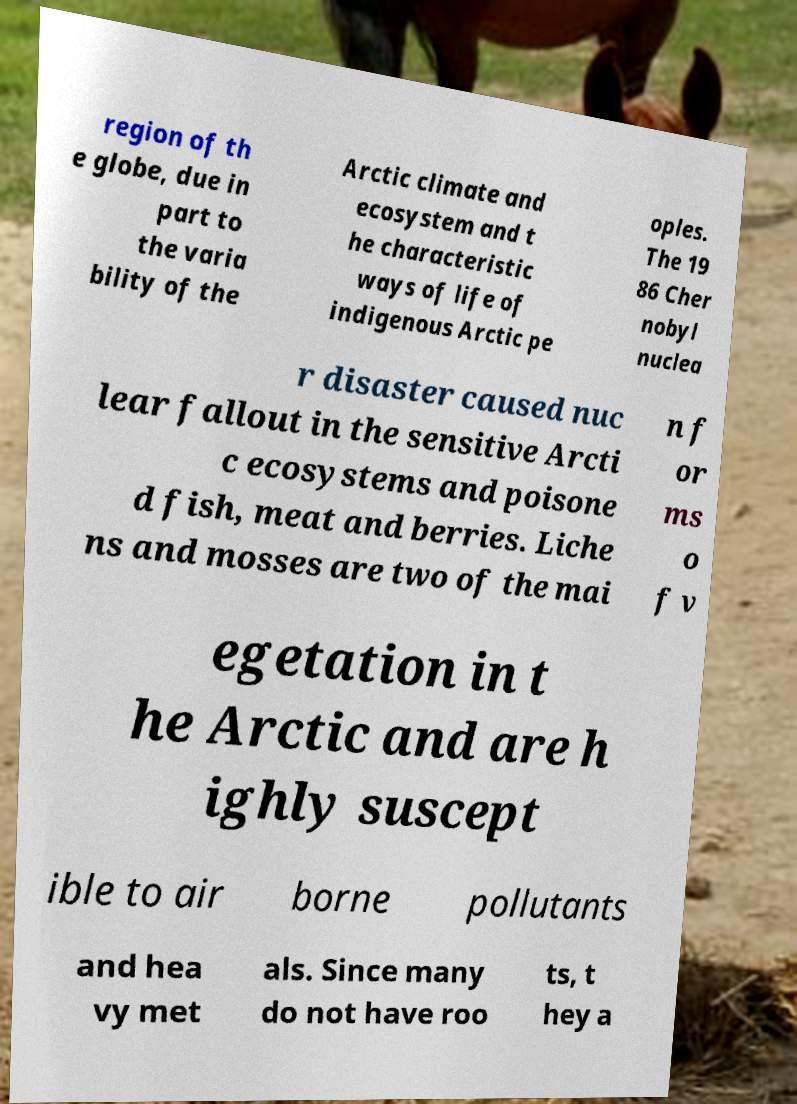What messages or text are displayed in this image? I need them in a readable, typed format. region of th e globe, due in part to the varia bility of the Arctic climate and ecosystem and t he characteristic ways of life of indigenous Arctic pe oples. The 19 86 Cher nobyl nuclea r disaster caused nuc lear fallout in the sensitive Arcti c ecosystems and poisone d fish, meat and berries. Liche ns and mosses are two of the mai n f or ms o f v egetation in t he Arctic and are h ighly suscept ible to air borne pollutants and hea vy met als. Since many do not have roo ts, t hey a 